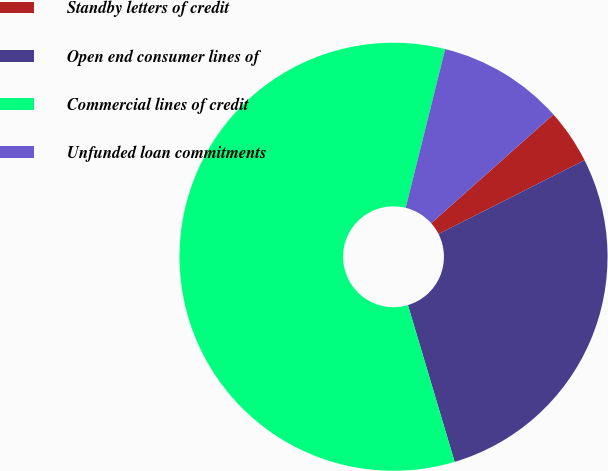<chart> <loc_0><loc_0><loc_500><loc_500><pie_chart><fcel>Standby letters of credit<fcel>Open end consumer lines of<fcel>Commercial lines of credit<fcel>Unfunded loan commitments<nl><fcel>4.12%<fcel>27.84%<fcel>58.49%<fcel>9.55%<nl></chart> 